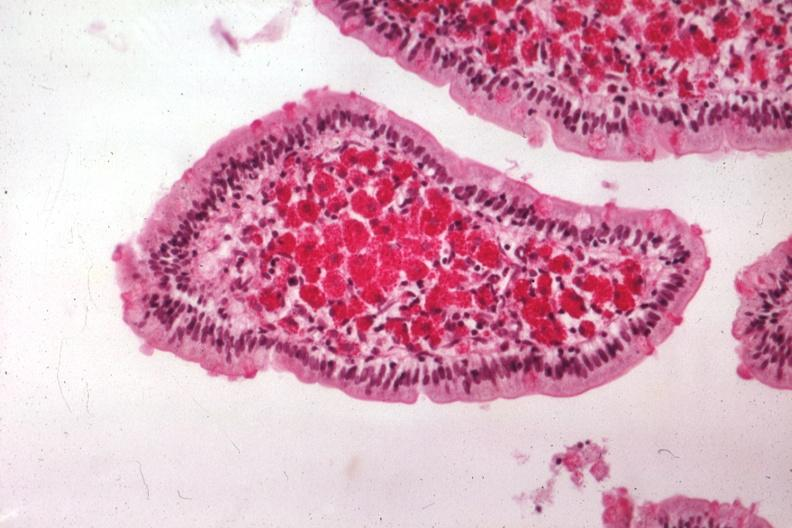s intestine present?
Answer the question using a single word or phrase. Yes 